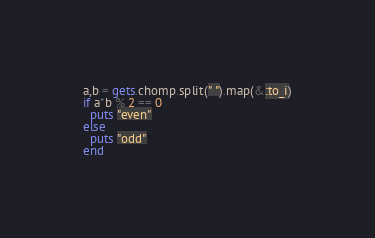<code> <loc_0><loc_0><loc_500><loc_500><_Ruby_>a,b = gets.chomp.split(" ").map(&:to_i)
if a*b % 2 == 0
  puts "even"
else
  puts "odd"
end
</code> 